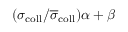Convert formula to latex. <formula><loc_0><loc_0><loc_500><loc_500>( \sigma _ { c o l l } / \overline { \sigma } _ { c o l l } ) \alpha + \beta</formula> 